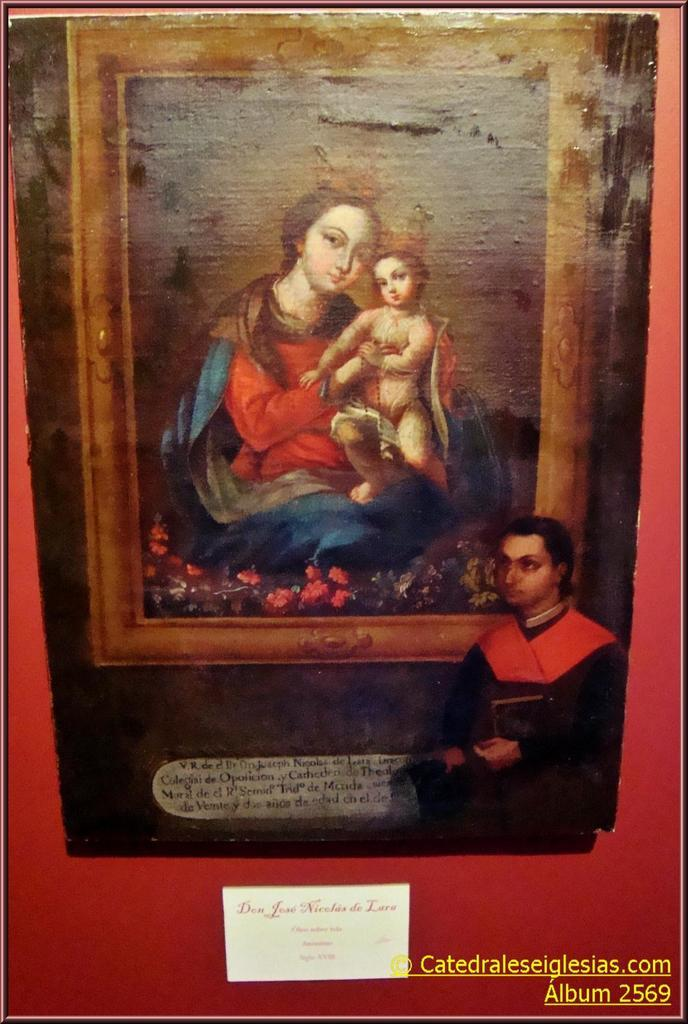What is the main subject in the foreground of the image? There is a poster in the foreground of the image. What is depicted on the poster? The poster features a woman holding a baby. What other elements are included in the scene on the poster? The scene in the poster includes flowered plants. Who else is present in the image besides the poster? There is a man in the image who is watching the poster. How does the grape contribute to the scene in the poster? There is no grape present in the image or the poster. What type of vessel is used to hold the baby in the poster? The woman in the poster is holding the baby, and there is no vessel involved. 